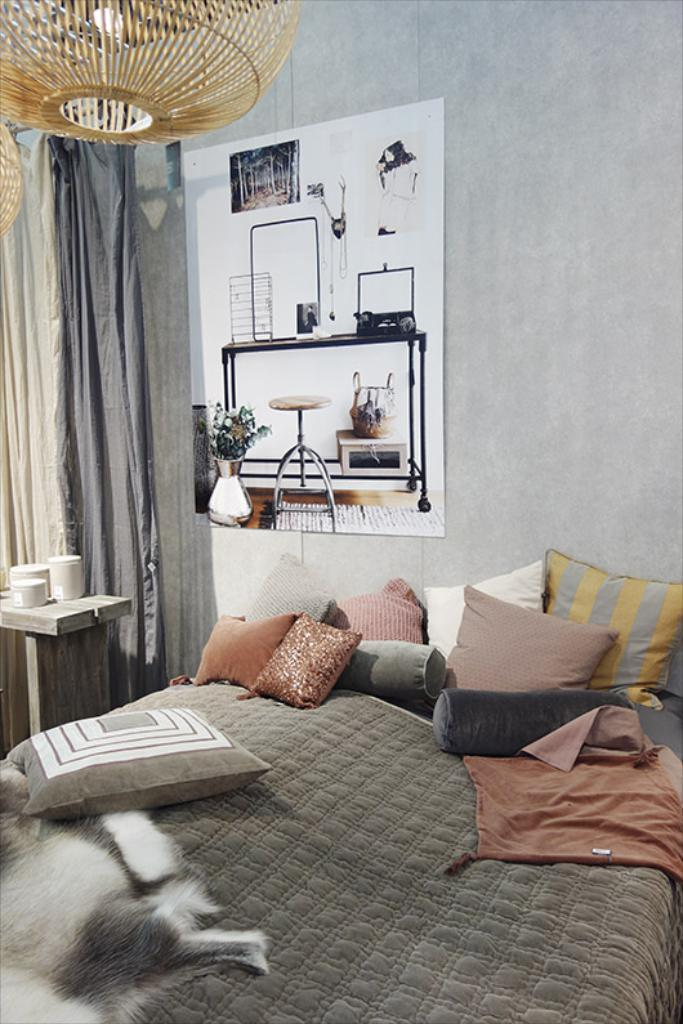What is the setting of the image? The image is inside a room. What furniture can be seen in the room? There is a bed with a bed-sheet and pillows in the room. What decoration is on the wall? There is a poster on the wall. What items are on the table? There are cups on a table. What type of animal is laying on the bed? There is an animal laying on the bed. What window treatment is present in the room? There is a curtain in the room. What type of authority figure can be seen in the image? There is no authority figure present in the image. What type of jam is being served on the table in the image? There is no jam present in the image; only cups are visible on the table. 